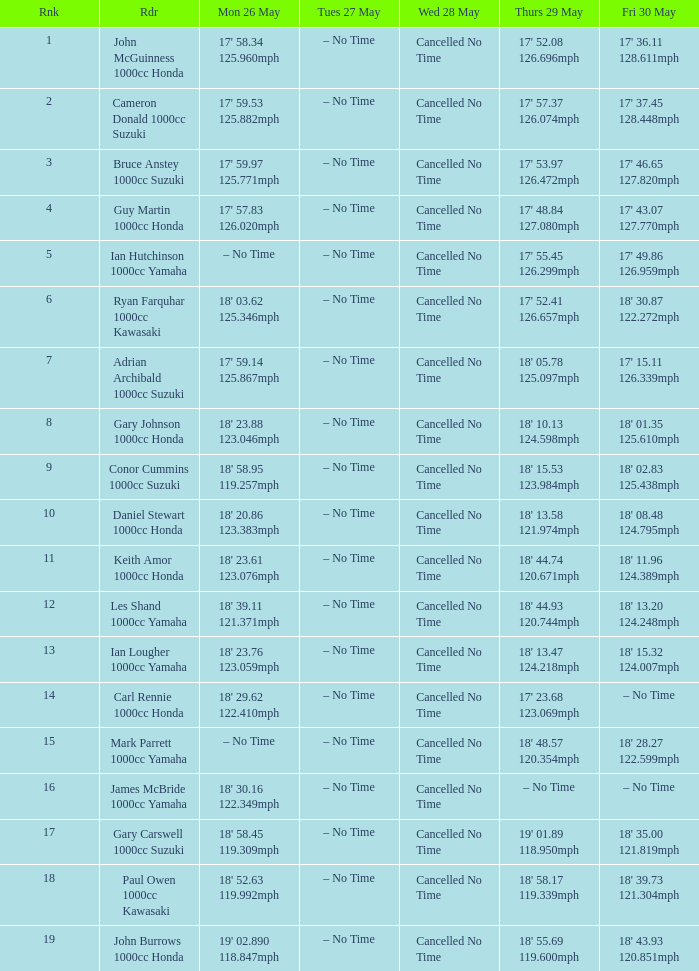What tims is wed may 28 and mon may 26 is 17' 58.34 125.960mph? Cancelled No Time. 